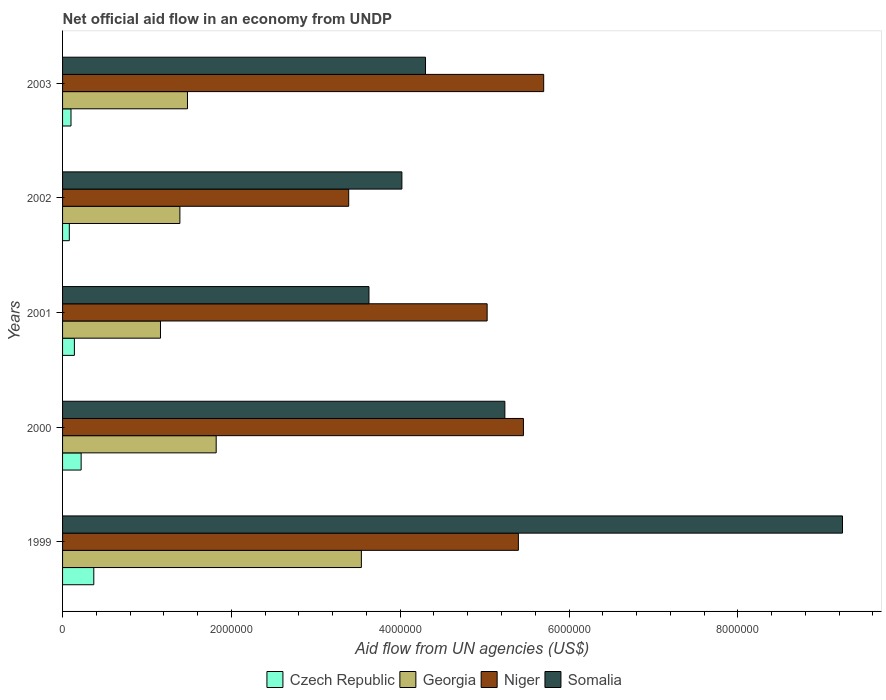Are the number of bars per tick equal to the number of legend labels?
Give a very brief answer. Yes. Are the number of bars on each tick of the Y-axis equal?
Your answer should be very brief. Yes. How many bars are there on the 4th tick from the top?
Offer a very short reply. 4. In how many cases, is the number of bars for a given year not equal to the number of legend labels?
Make the answer very short. 0. Across all years, what is the maximum net official aid flow in Niger?
Offer a terse response. 5.70e+06. Across all years, what is the minimum net official aid flow in Somalia?
Your answer should be compact. 3.63e+06. In which year was the net official aid flow in Georgia minimum?
Offer a very short reply. 2001. What is the total net official aid flow in Niger in the graph?
Provide a short and direct response. 2.50e+07. What is the difference between the net official aid flow in Czech Republic in 1999 and that in 2000?
Keep it short and to the point. 1.50e+05. What is the difference between the net official aid flow in Niger in 1999 and the net official aid flow in Georgia in 2002?
Your answer should be compact. 4.01e+06. What is the average net official aid flow in Somalia per year?
Offer a very short reply. 5.29e+06. In the year 2003, what is the difference between the net official aid flow in Georgia and net official aid flow in Niger?
Keep it short and to the point. -4.22e+06. In how many years, is the net official aid flow in Georgia greater than 8800000 US$?
Your answer should be very brief. 0. What is the ratio of the net official aid flow in Somalia in 2001 to that in 2002?
Your answer should be very brief. 0.9. What is the difference between the highest and the lowest net official aid flow in Georgia?
Your answer should be very brief. 2.38e+06. In how many years, is the net official aid flow in Georgia greater than the average net official aid flow in Georgia taken over all years?
Ensure brevity in your answer.  1. Is it the case that in every year, the sum of the net official aid flow in Czech Republic and net official aid flow in Georgia is greater than the sum of net official aid flow in Niger and net official aid flow in Somalia?
Provide a succinct answer. No. What does the 2nd bar from the top in 2001 represents?
Offer a very short reply. Niger. What does the 1st bar from the bottom in 2002 represents?
Your answer should be compact. Czech Republic. Is it the case that in every year, the sum of the net official aid flow in Czech Republic and net official aid flow in Niger is greater than the net official aid flow in Somalia?
Provide a succinct answer. No. How many years are there in the graph?
Your response must be concise. 5. Are the values on the major ticks of X-axis written in scientific E-notation?
Keep it short and to the point. No. Does the graph contain grids?
Offer a very short reply. No. Where does the legend appear in the graph?
Your answer should be compact. Bottom center. What is the title of the graph?
Make the answer very short. Net official aid flow in an economy from UNDP. Does "Arab World" appear as one of the legend labels in the graph?
Provide a short and direct response. No. What is the label or title of the X-axis?
Provide a short and direct response. Aid flow from UN agencies (US$). What is the label or title of the Y-axis?
Offer a terse response. Years. What is the Aid flow from UN agencies (US$) in Czech Republic in 1999?
Provide a succinct answer. 3.70e+05. What is the Aid flow from UN agencies (US$) of Georgia in 1999?
Your response must be concise. 3.54e+06. What is the Aid flow from UN agencies (US$) of Niger in 1999?
Provide a short and direct response. 5.40e+06. What is the Aid flow from UN agencies (US$) in Somalia in 1999?
Your answer should be compact. 9.24e+06. What is the Aid flow from UN agencies (US$) of Georgia in 2000?
Provide a succinct answer. 1.82e+06. What is the Aid flow from UN agencies (US$) of Niger in 2000?
Your answer should be compact. 5.46e+06. What is the Aid flow from UN agencies (US$) of Somalia in 2000?
Your answer should be very brief. 5.24e+06. What is the Aid flow from UN agencies (US$) in Georgia in 2001?
Your answer should be compact. 1.16e+06. What is the Aid flow from UN agencies (US$) of Niger in 2001?
Provide a short and direct response. 5.03e+06. What is the Aid flow from UN agencies (US$) of Somalia in 2001?
Your answer should be compact. 3.63e+06. What is the Aid flow from UN agencies (US$) of Georgia in 2002?
Offer a terse response. 1.39e+06. What is the Aid flow from UN agencies (US$) of Niger in 2002?
Your answer should be compact. 3.39e+06. What is the Aid flow from UN agencies (US$) of Somalia in 2002?
Offer a very short reply. 4.02e+06. What is the Aid flow from UN agencies (US$) of Georgia in 2003?
Your answer should be very brief. 1.48e+06. What is the Aid flow from UN agencies (US$) in Niger in 2003?
Your response must be concise. 5.70e+06. What is the Aid flow from UN agencies (US$) in Somalia in 2003?
Make the answer very short. 4.30e+06. Across all years, what is the maximum Aid flow from UN agencies (US$) of Georgia?
Your answer should be very brief. 3.54e+06. Across all years, what is the maximum Aid flow from UN agencies (US$) in Niger?
Offer a terse response. 5.70e+06. Across all years, what is the maximum Aid flow from UN agencies (US$) of Somalia?
Provide a short and direct response. 9.24e+06. Across all years, what is the minimum Aid flow from UN agencies (US$) of Czech Republic?
Make the answer very short. 8.00e+04. Across all years, what is the minimum Aid flow from UN agencies (US$) in Georgia?
Give a very brief answer. 1.16e+06. Across all years, what is the minimum Aid flow from UN agencies (US$) of Niger?
Offer a very short reply. 3.39e+06. Across all years, what is the minimum Aid flow from UN agencies (US$) of Somalia?
Your response must be concise. 3.63e+06. What is the total Aid flow from UN agencies (US$) in Czech Republic in the graph?
Your answer should be compact. 9.10e+05. What is the total Aid flow from UN agencies (US$) in Georgia in the graph?
Give a very brief answer. 9.39e+06. What is the total Aid flow from UN agencies (US$) in Niger in the graph?
Give a very brief answer. 2.50e+07. What is the total Aid flow from UN agencies (US$) of Somalia in the graph?
Keep it short and to the point. 2.64e+07. What is the difference between the Aid flow from UN agencies (US$) in Georgia in 1999 and that in 2000?
Make the answer very short. 1.72e+06. What is the difference between the Aid flow from UN agencies (US$) in Niger in 1999 and that in 2000?
Keep it short and to the point. -6.00e+04. What is the difference between the Aid flow from UN agencies (US$) in Georgia in 1999 and that in 2001?
Your answer should be compact. 2.38e+06. What is the difference between the Aid flow from UN agencies (US$) in Somalia in 1999 and that in 2001?
Make the answer very short. 5.61e+06. What is the difference between the Aid flow from UN agencies (US$) of Czech Republic in 1999 and that in 2002?
Provide a short and direct response. 2.90e+05. What is the difference between the Aid flow from UN agencies (US$) of Georgia in 1999 and that in 2002?
Offer a terse response. 2.15e+06. What is the difference between the Aid flow from UN agencies (US$) in Niger in 1999 and that in 2002?
Your response must be concise. 2.01e+06. What is the difference between the Aid flow from UN agencies (US$) of Somalia in 1999 and that in 2002?
Your response must be concise. 5.22e+06. What is the difference between the Aid flow from UN agencies (US$) of Georgia in 1999 and that in 2003?
Make the answer very short. 2.06e+06. What is the difference between the Aid flow from UN agencies (US$) of Somalia in 1999 and that in 2003?
Keep it short and to the point. 4.94e+06. What is the difference between the Aid flow from UN agencies (US$) of Georgia in 2000 and that in 2001?
Provide a succinct answer. 6.60e+05. What is the difference between the Aid flow from UN agencies (US$) in Somalia in 2000 and that in 2001?
Offer a terse response. 1.61e+06. What is the difference between the Aid flow from UN agencies (US$) in Niger in 2000 and that in 2002?
Your answer should be compact. 2.07e+06. What is the difference between the Aid flow from UN agencies (US$) of Somalia in 2000 and that in 2002?
Keep it short and to the point. 1.22e+06. What is the difference between the Aid flow from UN agencies (US$) of Somalia in 2000 and that in 2003?
Your answer should be compact. 9.40e+05. What is the difference between the Aid flow from UN agencies (US$) of Georgia in 2001 and that in 2002?
Keep it short and to the point. -2.30e+05. What is the difference between the Aid flow from UN agencies (US$) of Niger in 2001 and that in 2002?
Give a very brief answer. 1.64e+06. What is the difference between the Aid flow from UN agencies (US$) of Somalia in 2001 and that in 2002?
Your answer should be very brief. -3.90e+05. What is the difference between the Aid flow from UN agencies (US$) of Georgia in 2001 and that in 2003?
Provide a short and direct response. -3.20e+05. What is the difference between the Aid flow from UN agencies (US$) in Niger in 2001 and that in 2003?
Provide a short and direct response. -6.70e+05. What is the difference between the Aid flow from UN agencies (US$) of Somalia in 2001 and that in 2003?
Make the answer very short. -6.70e+05. What is the difference between the Aid flow from UN agencies (US$) of Czech Republic in 2002 and that in 2003?
Offer a terse response. -2.00e+04. What is the difference between the Aid flow from UN agencies (US$) of Georgia in 2002 and that in 2003?
Ensure brevity in your answer.  -9.00e+04. What is the difference between the Aid flow from UN agencies (US$) in Niger in 2002 and that in 2003?
Offer a terse response. -2.31e+06. What is the difference between the Aid flow from UN agencies (US$) in Somalia in 2002 and that in 2003?
Offer a very short reply. -2.80e+05. What is the difference between the Aid flow from UN agencies (US$) in Czech Republic in 1999 and the Aid flow from UN agencies (US$) in Georgia in 2000?
Make the answer very short. -1.45e+06. What is the difference between the Aid flow from UN agencies (US$) in Czech Republic in 1999 and the Aid flow from UN agencies (US$) in Niger in 2000?
Keep it short and to the point. -5.09e+06. What is the difference between the Aid flow from UN agencies (US$) of Czech Republic in 1999 and the Aid flow from UN agencies (US$) of Somalia in 2000?
Your response must be concise. -4.87e+06. What is the difference between the Aid flow from UN agencies (US$) of Georgia in 1999 and the Aid flow from UN agencies (US$) of Niger in 2000?
Offer a very short reply. -1.92e+06. What is the difference between the Aid flow from UN agencies (US$) of Georgia in 1999 and the Aid flow from UN agencies (US$) of Somalia in 2000?
Offer a very short reply. -1.70e+06. What is the difference between the Aid flow from UN agencies (US$) of Czech Republic in 1999 and the Aid flow from UN agencies (US$) of Georgia in 2001?
Keep it short and to the point. -7.90e+05. What is the difference between the Aid flow from UN agencies (US$) of Czech Republic in 1999 and the Aid flow from UN agencies (US$) of Niger in 2001?
Offer a very short reply. -4.66e+06. What is the difference between the Aid flow from UN agencies (US$) in Czech Republic in 1999 and the Aid flow from UN agencies (US$) in Somalia in 2001?
Your answer should be compact. -3.26e+06. What is the difference between the Aid flow from UN agencies (US$) in Georgia in 1999 and the Aid flow from UN agencies (US$) in Niger in 2001?
Your response must be concise. -1.49e+06. What is the difference between the Aid flow from UN agencies (US$) in Niger in 1999 and the Aid flow from UN agencies (US$) in Somalia in 2001?
Provide a succinct answer. 1.77e+06. What is the difference between the Aid flow from UN agencies (US$) in Czech Republic in 1999 and the Aid flow from UN agencies (US$) in Georgia in 2002?
Make the answer very short. -1.02e+06. What is the difference between the Aid flow from UN agencies (US$) in Czech Republic in 1999 and the Aid flow from UN agencies (US$) in Niger in 2002?
Ensure brevity in your answer.  -3.02e+06. What is the difference between the Aid flow from UN agencies (US$) of Czech Republic in 1999 and the Aid flow from UN agencies (US$) of Somalia in 2002?
Ensure brevity in your answer.  -3.65e+06. What is the difference between the Aid flow from UN agencies (US$) in Georgia in 1999 and the Aid flow from UN agencies (US$) in Somalia in 2002?
Offer a very short reply. -4.80e+05. What is the difference between the Aid flow from UN agencies (US$) in Niger in 1999 and the Aid flow from UN agencies (US$) in Somalia in 2002?
Provide a short and direct response. 1.38e+06. What is the difference between the Aid flow from UN agencies (US$) of Czech Republic in 1999 and the Aid flow from UN agencies (US$) of Georgia in 2003?
Offer a terse response. -1.11e+06. What is the difference between the Aid flow from UN agencies (US$) in Czech Republic in 1999 and the Aid flow from UN agencies (US$) in Niger in 2003?
Offer a terse response. -5.33e+06. What is the difference between the Aid flow from UN agencies (US$) in Czech Republic in 1999 and the Aid flow from UN agencies (US$) in Somalia in 2003?
Ensure brevity in your answer.  -3.93e+06. What is the difference between the Aid flow from UN agencies (US$) of Georgia in 1999 and the Aid flow from UN agencies (US$) of Niger in 2003?
Your response must be concise. -2.16e+06. What is the difference between the Aid flow from UN agencies (US$) in Georgia in 1999 and the Aid flow from UN agencies (US$) in Somalia in 2003?
Provide a succinct answer. -7.60e+05. What is the difference between the Aid flow from UN agencies (US$) of Niger in 1999 and the Aid flow from UN agencies (US$) of Somalia in 2003?
Your response must be concise. 1.10e+06. What is the difference between the Aid flow from UN agencies (US$) in Czech Republic in 2000 and the Aid flow from UN agencies (US$) in Georgia in 2001?
Provide a succinct answer. -9.40e+05. What is the difference between the Aid flow from UN agencies (US$) in Czech Republic in 2000 and the Aid flow from UN agencies (US$) in Niger in 2001?
Provide a short and direct response. -4.81e+06. What is the difference between the Aid flow from UN agencies (US$) of Czech Republic in 2000 and the Aid flow from UN agencies (US$) of Somalia in 2001?
Your response must be concise. -3.41e+06. What is the difference between the Aid flow from UN agencies (US$) of Georgia in 2000 and the Aid flow from UN agencies (US$) of Niger in 2001?
Ensure brevity in your answer.  -3.21e+06. What is the difference between the Aid flow from UN agencies (US$) in Georgia in 2000 and the Aid flow from UN agencies (US$) in Somalia in 2001?
Your answer should be very brief. -1.81e+06. What is the difference between the Aid flow from UN agencies (US$) of Niger in 2000 and the Aid flow from UN agencies (US$) of Somalia in 2001?
Keep it short and to the point. 1.83e+06. What is the difference between the Aid flow from UN agencies (US$) in Czech Republic in 2000 and the Aid flow from UN agencies (US$) in Georgia in 2002?
Your answer should be compact. -1.17e+06. What is the difference between the Aid flow from UN agencies (US$) in Czech Republic in 2000 and the Aid flow from UN agencies (US$) in Niger in 2002?
Provide a short and direct response. -3.17e+06. What is the difference between the Aid flow from UN agencies (US$) of Czech Republic in 2000 and the Aid flow from UN agencies (US$) of Somalia in 2002?
Your answer should be very brief. -3.80e+06. What is the difference between the Aid flow from UN agencies (US$) in Georgia in 2000 and the Aid flow from UN agencies (US$) in Niger in 2002?
Your answer should be compact. -1.57e+06. What is the difference between the Aid flow from UN agencies (US$) of Georgia in 2000 and the Aid flow from UN agencies (US$) of Somalia in 2002?
Provide a short and direct response. -2.20e+06. What is the difference between the Aid flow from UN agencies (US$) of Niger in 2000 and the Aid flow from UN agencies (US$) of Somalia in 2002?
Provide a succinct answer. 1.44e+06. What is the difference between the Aid flow from UN agencies (US$) in Czech Republic in 2000 and the Aid flow from UN agencies (US$) in Georgia in 2003?
Keep it short and to the point. -1.26e+06. What is the difference between the Aid flow from UN agencies (US$) in Czech Republic in 2000 and the Aid flow from UN agencies (US$) in Niger in 2003?
Provide a short and direct response. -5.48e+06. What is the difference between the Aid flow from UN agencies (US$) in Czech Republic in 2000 and the Aid flow from UN agencies (US$) in Somalia in 2003?
Provide a short and direct response. -4.08e+06. What is the difference between the Aid flow from UN agencies (US$) in Georgia in 2000 and the Aid flow from UN agencies (US$) in Niger in 2003?
Offer a terse response. -3.88e+06. What is the difference between the Aid flow from UN agencies (US$) of Georgia in 2000 and the Aid flow from UN agencies (US$) of Somalia in 2003?
Keep it short and to the point. -2.48e+06. What is the difference between the Aid flow from UN agencies (US$) in Niger in 2000 and the Aid flow from UN agencies (US$) in Somalia in 2003?
Keep it short and to the point. 1.16e+06. What is the difference between the Aid flow from UN agencies (US$) in Czech Republic in 2001 and the Aid flow from UN agencies (US$) in Georgia in 2002?
Ensure brevity in your answer.  -1.25e+06. What is the difference between the Aid flow from UN agencies (US$) of Czech Republic in 2001 and the Aid flow from UN agencies (US$) of Niger in 2002?
Offer a terse response. -3.25e+06. What is the difference between the Aid flow from UN agencies (US$) of Czech Republic in 2001 and the Aid flow from UN agencies (US$) of Somalia in 2002?
Keep it short and to the point. -3.88e+06. What is the difference between the Aid flow from UN agencies (US$) of Georgia in 2001 and the Aid flow from UN agencies (US$) of Niger in 2002?
Give a very brief answer. -2.23e+06. What is the difference between the Aid flow from UN agencies (US$) of Georgia in 2001 and the Aid flow from UN agencies (US$) of Somalia in 2002?
Keep it short and to the point. -2.86e+06. What is the difference between the Aid flow from UN agencies (US$) in Niger in 2001 and the Aid flow from UN agencies (US$) in Somalia in 2002?
Your answer should be very brief. 1.01e+06. What is the difference between the Aid flow from UN agencies (US$) of Czech Republic in 2001 and the Aid flow from UN agencies (US$) of Georgia in 2003?
Provide a succinct answer. -1.34e+06. What is the difference between the Aid flow from UN agencies (US$) of Czech Republic in 2001 and the Aid flow from UN agencies (US$) of Niger in 2003?
Your answer should be very brief. -5.56e+06. What is the difference between the Aid flow from UN agencies (US$) in Czech Republic in 2001 and the Aid flow from UN agencies (US$) in Somalia in 2003?
Provide a succinct answer. -4.16e+06. What is the difference between the Aid flow from UN agencies (US$) of Georgia in 2001 and the Aid flow from UN agencies (US$) of Niger in 2003?
Ensure brevity in your answer.  -4.54e+06. What is the difference between the Aid flow from UN agencies (US$) of Georgia in 2001 and the Aid flow from UN agencies (US$) of Somalia in 2003?
Your answer should be very brief. -3.14e+06. What is the difference between the Aid flow from UN agencies (US$) in Niger in 2001 and the Aid flow from UN agencies (US$) in Somalia in 2003?
Offer a very short reply. 7.30e+05. What is the difference between the Aid flow from UN agencies (US$) of Czech Republic in 2002 and the Aid flow from UN agencies (US$) of Georgia in 2003?
Offer a terse response. -1.40e+06. What is the difference between the Aid flow from UN agencies (US$) of Czech Republic in 2002 and the Aid flow from UN agencies (US$) of Niger in 2003?
Make the answer very short. -5.62e+06. What is the difference between the Aid flow from UN agencies (US$) in Czech Republic in 2002 and the Aid flow from UN agencies (US$) in Somalia in 2003?
Keep it short and to the point. -4.22e+06. What is the difference between the Aid flow from UN agencies (US$) in Georgia in 2002 and the Aid flow from UN agencies (US$) in Niger in 2003?
Ensure brevity in your answer.  -4.31e+06. What is the difference between the Aid flow from UN agencies (US$) in Georgia in 2002 and the Aid flow from UN agencies (US$) in Somalia in 2003?
Your answer should be very brief. -2.91e+06. What is the difference between the Aid flow from UN agencies (US$) of Niger in 2002 and the Aid flow from UN agencies (US$) of Somalia in 2003?
Make the answer very short. -9.10e+05. What is the average Aid flow from UN agencies (US$) in Czech Republic per year?
Ensure brevity in your answer.  1.82e+05. What is the average Aid flow from UN agencies (US$) of Georgia per year?
Your answer should be very brief. 1.88e+06. What is the average Aid flow from UN agencies (US$) in Niger per year?
Provide a succinct answer. 5.00e+06. What is the average Aid flow from UN agencies (US$) of Somalia per year?
Your answer should be compact. 5.29e+06. In the year 1999, what is the difference between the Aid flow from UN agencies (US$) of Czech Republic and Aid flow from UN agencies (US$) of Georgia?
Make the answer very short. -3.17e+06. In the year 1999, what is the difference between the Aid flow from UN agencies (US$) of Czech Republic and Aid flow from UN agencies (US$) of Niger?
Keep it short and to the point. -5.03e+06. In the year 1999, what is the difference between the Aid flow from UN agencies (US$) of Czech Republic and Aid flow from UN agencies (US$) of Somalia?
Offer a very short reply. -8.87e+06. In the year 1999, what is the difference between the Aid flow from UN agencies (US$) in Georgia and Aid flow from UN agencies (US$) in Niger?
Offer a very short reply. -1.86e+06. In the year 1999, what is the difference between the Aid flow from UN agencies (US$) of Georgia and Aid flow from UN agencies (US$) of Somalia?
Keep it short and to the point. -5.70e+06. In the year 1999, what is the difference between the Aid flow from UN agencies (US$) in Niger and Aid flow from UN agencies (US$) in Somalia?
Your response must be concise. -3.84e+06. In the year 2000, what is the difference between the Aid flow from UN agencies (US$) in Czech Republic and Aid flow from UN agencies (US$) in Georgia?
Ensure brevity in your answer.  -1.60e+06. In the year 2000, what is the difference between the Aid flow from UN agencies (US$) of Czech Republic and Aid flow from UN agencies (US$) of Niger?
Provide a succinct answer. -5.24e+06. In the year 2000, what is the difference between the Aid flow from UN agencies (US$) of Czech Republic and Aid flow from UN agencies (US$) of Somalia?
Ensure brevity in your answer.  -5.02e+06. In the year 2000, what is the difference between the Aid flow from UN agencies (US$) of Georgia and Aid flow from UN agencies (US$) of Niger?
Offer a very short reply. -3.64e+06. In the year 2000, what is the difference between the Aid flow from UN agencies (US$) of Georgia and Aid flow from UN agencies (US$) of Somalia?
Your answer should be very brief. -3.42e+06. In the year 2001, what is the difference between the Aid flow from UN agencies (US$) in Czech Republic and Aid flow from UN agencies (US$) in Georgia?
Offer a terse response. -1.02e+06. In the year 2001, what is the difference between the Aid flow from UN agencies (US$) in Czech Republic and Aid flow from UN agencies (US$) in Niger?
Ensure brevity in your answer.  -4.89e+06. In the year 2001, what is the difference between the Aid flow from UN agencies (US$) of Czech Republic and Aid flow from UN agencies (US$) of Somalia?
Give a very brief answer. -3.49e+06. In the year 2001, what is the difference between the Aid flow from UN agencies (US$) in Georgia and Aid flow from UN agencies (US$) in Niger?
Provide a succinct answer. -3.87e+06. In the year 2001, what is the difference between the Aid flow from UN agencies (US$) of Georgia and Aid flow from UN agencies (US$) of Somalia?
Provide a short and direct response. -2.47e+06. In the year 2001, what is the difference between the Aid flow from UN agencies (US$) of Niger and Aid flow from UN agencies (US$) of Somalia?
Offer a terse response. 1.40e+06. In the year 2002, what is the difference between the Aid flow from UN agencies (US$) of Czech Republic and Aid flow from UN agencies (US$) of Georgia?
Keep it short and to the point. -1.31e+06. In the year 2002, what is the difference between the Aid flow from UN agencies (US$) of Czech Republic and Aid flow from UN agencies (US$) of Niger?
Your answer should be compact. -3.31e+06. In the year 2002, what is the difference between the Aid flow from UN agencies (US$) in Czech Republic and Aid flow from UN agencies (US$) in Somalia?
Provide a succinct answer. -3.94e+06. In the year 2002, what is the difference between the Aid flow from UN agencies (US$) of Georgia and Aid flow from UN agencies (US$) of Somalia?
Offer a very short reply. -2.63e+06. In the year 2002, what is the difference between the Aid flow from UN agencies (US$) in Niger and Aid flow from UN agencies (US$) in Somalia?
Your response must be concise. -6.30e+05. In the year 2003, what is the difference between the Aid flow from UN agencies (US$) of Czech Republic and Aid flow from UN agencies (US$) of Georgia?
Your response must be concise. -1.38e+06. In the year 2003, what is the difference between the Aid flow from UN agencies (US$) of Czech Republic and Aid flow from UN agencies (US$) of Niger?
Provide a succinct answer. -5.60e+06. In the year 2003, what is the difference between the Aid flow from UN agencies (US$) of Czech Republic and Aid flow from UN agencies (US$) of Somalia?
Ensure brevity in your answer.  -4.20e+06. In the year 2003, what is the difference between the Aid flow from UN agencies (US$) of Georgia and Aid flow from UN agencies (US$) of Niger?
Make the answer very short. -4.22e+06. In the year 2003, what is the difference between the Aid flow from UN agencies (US$) of Georgia and Aid flow from UN agencies (US$) of Somalia?
Provide a succinct answer. -2.82e+06. In the year 2003, what is the difference between the Aid flow from UN agencies (US$) in Niger and Aid flow from UN agencies (US$) in Somalia?
Your answer should be very brief. 1.40e+06. What is the ratio of the Aid flow from UN agencies (US$) in Czech Republic in 1999 to that in 2000?
Your answer should be compact. 1.68. What is the ratio of the Aid flow from UN agencies (US$) in Georgia in 1999 to that in 2000?
Keep it short and to the point. 1.95. What is the ratio of the Aid flow from UN agencies (US$) of Niger in 1999 to that in 2000?
Ensure brevity in your answer.  0.99. What is the ratio of the Aid flow from UN agencies (US$) in Somalia in 1999 to that in 2000?
Ensure brevity in your answer.  1.76. What is the ratio of the Aid flow from UN agencies (US$) of Czech Republic in 1999 to that in 2001?
Keep it short and to the point. 2.64. What is the ratio of the Aid flow from UN agencies (US$) in Georgia in 1999 to that in 2001?
Offer a very short reply. 3.05. What is the ratio of the Aid flow from UN agencies (US$) in Niger in 1999 to that in 2001?
Provide a short and direct response. 1.07. What is the ratio of the Aid flow from UN agencies (US$) of Somalia in 1999 to that in 2001?
Make the answer very short. 2.55. What is the ratio of the Aid flow from UN agencies (US$) of Czech Republic in 1999 to that in 2002?
Your answer should be compact. 4.62. What is the ratio of the Aid flow from UN agencies (US$) in Georgia in 1999 to that in 2002?
Provide a short and direct response. 2.55. What is the ratio of the Aid flow from UN agencies (US$) in Niger in 1999 to that in 2002?
Offer a very short reply. 1.59. What is the ratio of the Aid flow from UN agencies (US$) of Somalia in 1999 to that in 2002?
Give a very brief answer. 2.3. What is the ratio of the Aid flow from UN agencies (US$) of Georgia in 1999 to that in 2003?
Keep it short and to the point. 2.39. What is the ratio of the Aid flow from UN agencies (US$) in Niger in 1999 to that in 2003?
Make the answer very short. 0.95. What is the ratio of the Aid flow from UN agencies (US$) of Somalia in 1999 to that in 2003?
Offer a terse response. 2.15. What is the ratio of the Aid flow from UN agencies (US$) in Czech Republic in 2000 to that in 2001?
Make the answer very short. 1.57. What is the ratio of the Aid flow from UN agencies (US$) of Georgia in 2000 to that in 2001?
Your answer should be very brief. 1.57. What is the ratio of the Aid flow from UN agencies (US$) of Niger in 2000 to that in 2001?
Provide a short and direct response. 1.09. What is the ratio of the Aid flow from UN agencies (US$) of Somalia in 2000 to that in 2001?
Offer a terse response. 1.44. What is the ratio of the Aid flow from UN agencies (US$) in Czech Republic in 2000 to that in 2002?
Make the answer very short. 2.75. What is the ratio of the Aid flow from UN agencies (US$) in Georgia in 2000 to that in 2002?
Keep it short and to the point. 1.31. What is the ratio of the Aid flow from UN agencies (US$) of Niger in 2000 to that in 2002?
Your answer should be compact. 1.61. What is the ratio of the Aid flow from UN agencies (US$) of Somalia in 2000 to that in 2002?
Offer a very short reply. 1.3. What is the ratio of the Aid flow from UN agencies (US$) in Georgia in 2000 to that in 2003?
Your answer should be very brief. 1.23. What is the ratio of the Aid flow from UN agencies (US$) of Niger in 2000 to that in 2003?
Provide a short and direct response. 0.96. What is the ratio of the Aid flow from UN agencies (US$) in Somalia in 2000 to that in 2003?
Provide a succinct answer. 1.22. What is the ratio of the Aid flow from UN agencies (US$) in Georgia in 2001 to that in 2002?
Give a very brief answer. 0.83. What is the ratio of the Aid flow from UN agencies (US$) in Niger in 2001 to that in 2002?
Provide a short and direct response. 1.48. What is the ratio of the Aid flow from UN agencies (US$) of Somalia in 2001 to that in 2002?
Provide a succinct answer. 0.9. What is the ratio of the Aid flow from UN agencies (US$) of Georgia in 2001 to that in 2003?
Provide a succinct answer. 0.78. What is the ratio of the Aid flow from UN agencies (US$) of Niger in 2001 to that in 2003?
Provide a succinct answer. 0.88. What is the ratio of the Aid flow from UN agencies (US$) of Somalia in 2001 to that in 2003?
Provide a short and direct response. 0.84. What is the ratio of the Aid flow from UN agencies (US$) in Georgia in 2002 to that in 2003?
Make the answer very short. 0.94. What is the ratio of the Aid flow from UN agencies (US$) of Niger in 2002 to that in 2003?
Provide a short and direct response. 0.59. What is the ratio of the Aid flow from UN agencies (US$) of Somalia in 2002 to that in 2003?
Make the answer very short. 0.93. What is the difference between the highest and the second highest Aid flow from UN agencies (US$) of Georgia?
Your answer should be compact. 1.72e+06. What is the difference between the highest and the lowest Aid flow from UN agencies (US$) in Georgia?
Your response must be concise. 2.38e+06. What is the difference between the highest and the lowest Aid flow from UN agencies (US$) of Niger?
Ensure brevity in your answer.  2.31e+06. What is the difference between the highest and the lowest Aid flow from UN agencies (US$) of Somalia?
Offer a very short reply. 5.61e+06. 